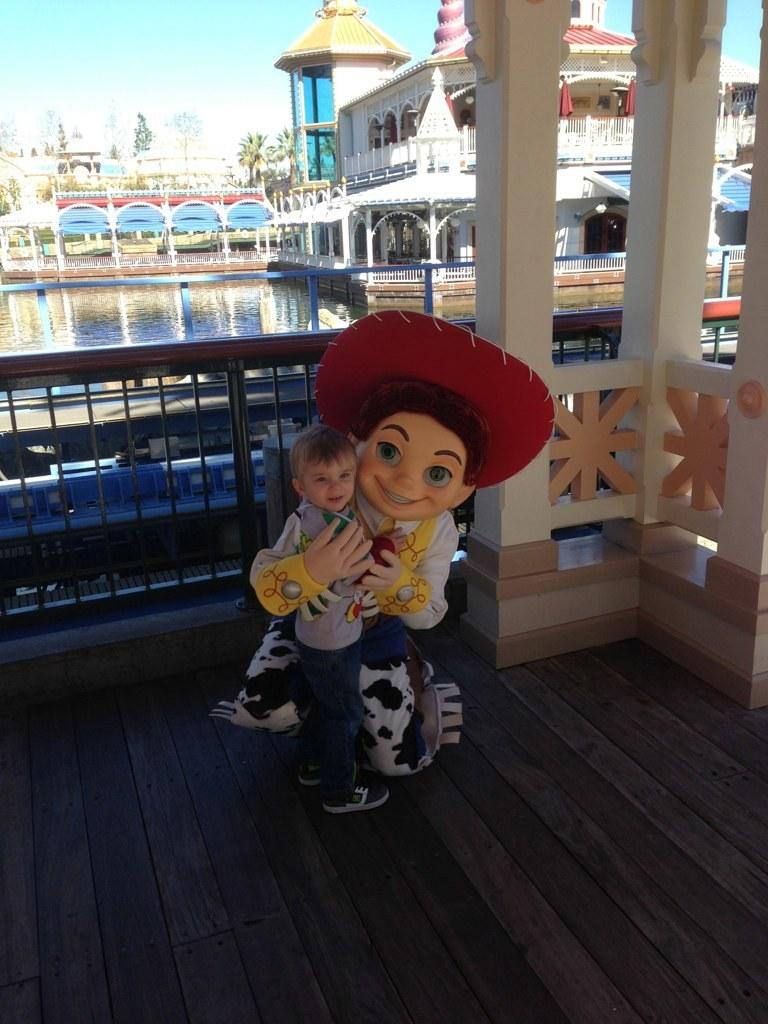What is the person in the image wearing? The person in the image is wearing a fancy dress. What is the person doing with the boy? The person is holding a boy. What can be seen in the background of the image? In the background of the image, there is a fence, water, trees, buildings, and the sky. What type of kettle is visible in the image? There is no kettle present in the image. How many shoes can be seen on the person's feet in the image? The image does not show the person's feet, so it is not possible to determine the number of shoes they are wearing. 